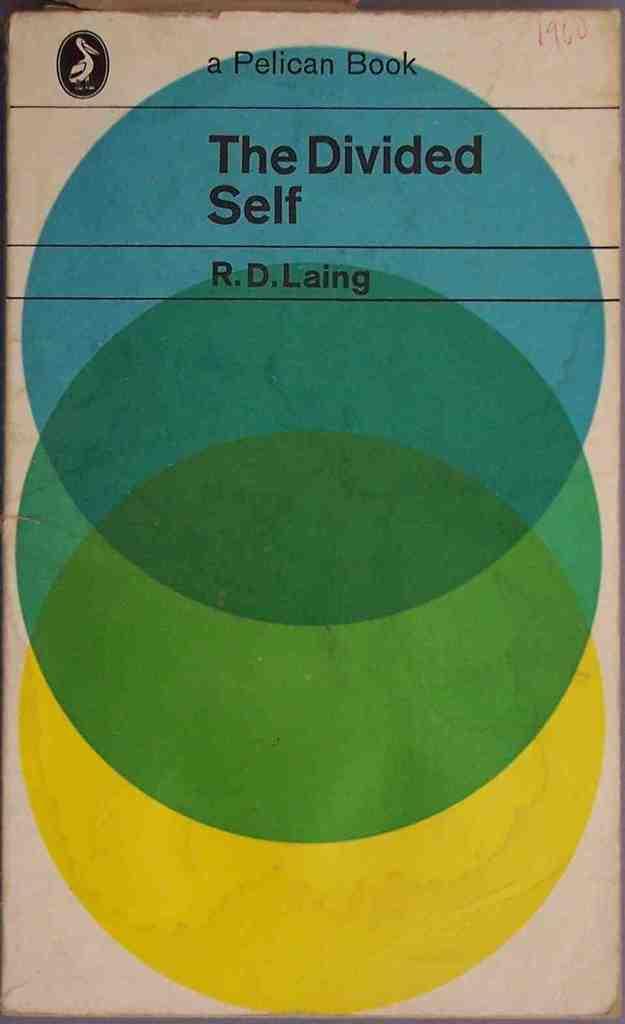Who is the author of this book?
Your answer should be very brief. R.d. laing. Who published this book?
Offer a terse response. Pelican. 